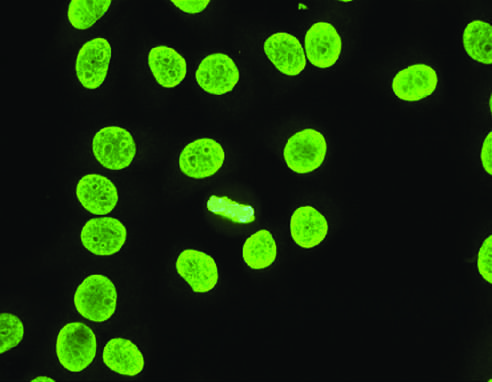where is homogeneous or diffuse staining of nuclei common?
Answer the question using a single word or phrase. In sle 